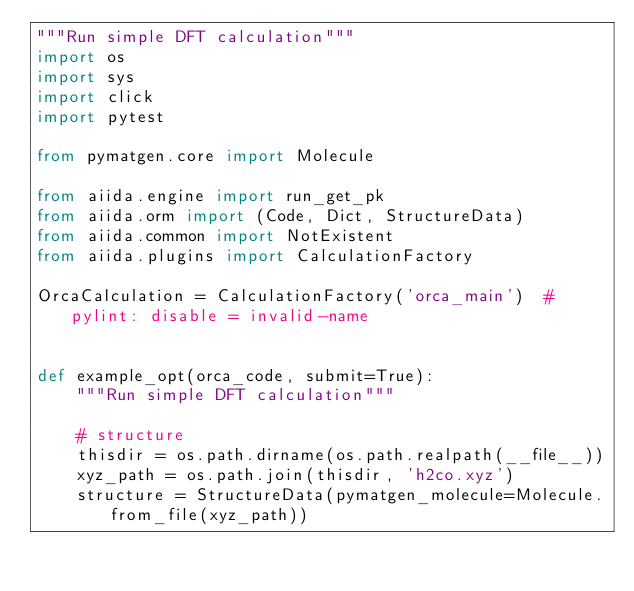Convert code to text. <code><loc_0><loc_0><loc_500><loc_500><_Python_>"""Run simple DFT calculation"""
import os
import sys
import click
import pytest

from pymatgen.core import Molecule

from aiida.engine import run_get_pk
from aiida.orm import (Code, Dict, StructureData)
from aiida.common import NotExistent
from aiida.plugins import CalculationFactory

OrcaCalculation = CalculationFactory('orca_main')  #pylint: disable = invalid-name


def example_opt(orca_code, submit=True):
    """Run simple DFT calculation"""

    # structure
    thisdir = os.path.dirname(os.path.realpath(__file__))
    xyz_path = os.path.join(thisdir, 'h2co.xyz')
    structure = StructureData(pymatgen_molecule=Molecule.from_file(xyz_path))
</code> 